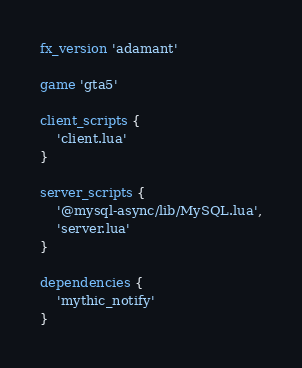<code> <loc_0><loc_0><loc_500><loc_500><_Lua_>fx_version 'adamant'

game 'gta5'

client_scripts {
	'client.lua'
}

server_scripts {
	'@mysql-async/lib/MySQL.lua',
	'server.lua'
}

dependencies {
	'mythic_notify'
}</code> 